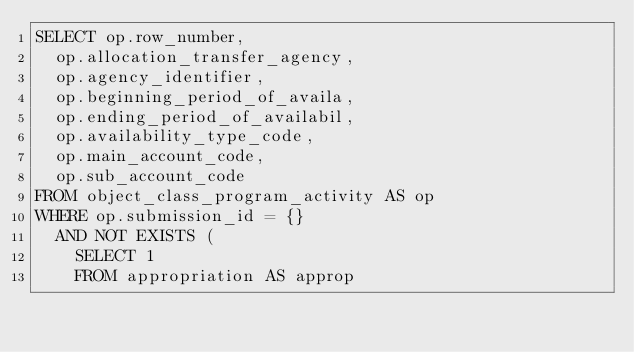<code> <loc_0><loc_0><loc_500><loc_500><_SQL_>SELECT op.row_number,
	op.allocation_transfer_agency,
	op.agency_identifier,
	op.beginning_period_of_availa,
	op.ending_period_of_availabil,
	op.availability_type_code,
	op.main_account_code,
	op.sub_account_code
FROM object_class_program_activity AS op
WHERE op.submission_id = {}
	AND NOT EXISTS (
		SELECT 1
		FROM appropriation AS approp</code> 